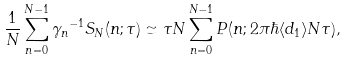<formula> <loc_0><loc_0><loc_500><loc_500>\frac { 1 } { N } \sum _ { n = 0 } ^ { N - 1 } { \gamma _ { n } } ^ { - 1 } S _ { N } ( n ; \tau ) \simeq \tau N \sum _ { n = 0 } ^ { N - 1 } P ( n ; 2 \pi \hbar { \langle } d _ { 1 } \rangle N \tau ) ,</formula> 